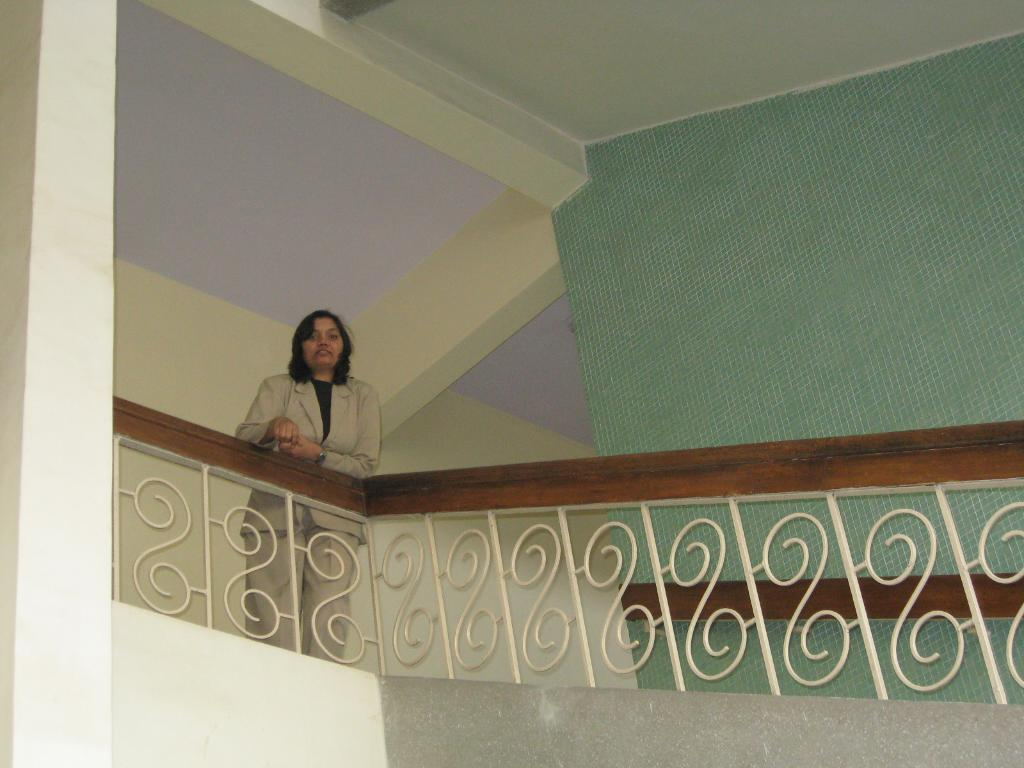What is the main subject of the image? There is a woman standing in the image. What objects can be seen near the woman? There are staircase holders visible in the image. What can be seen in the background of the image? There are walls visible in the background of the image. What type of history can be seen in the image? There is no specific historical event or reference visible in the image. Is there any snow present in the image? There is no snow visible in the image. 